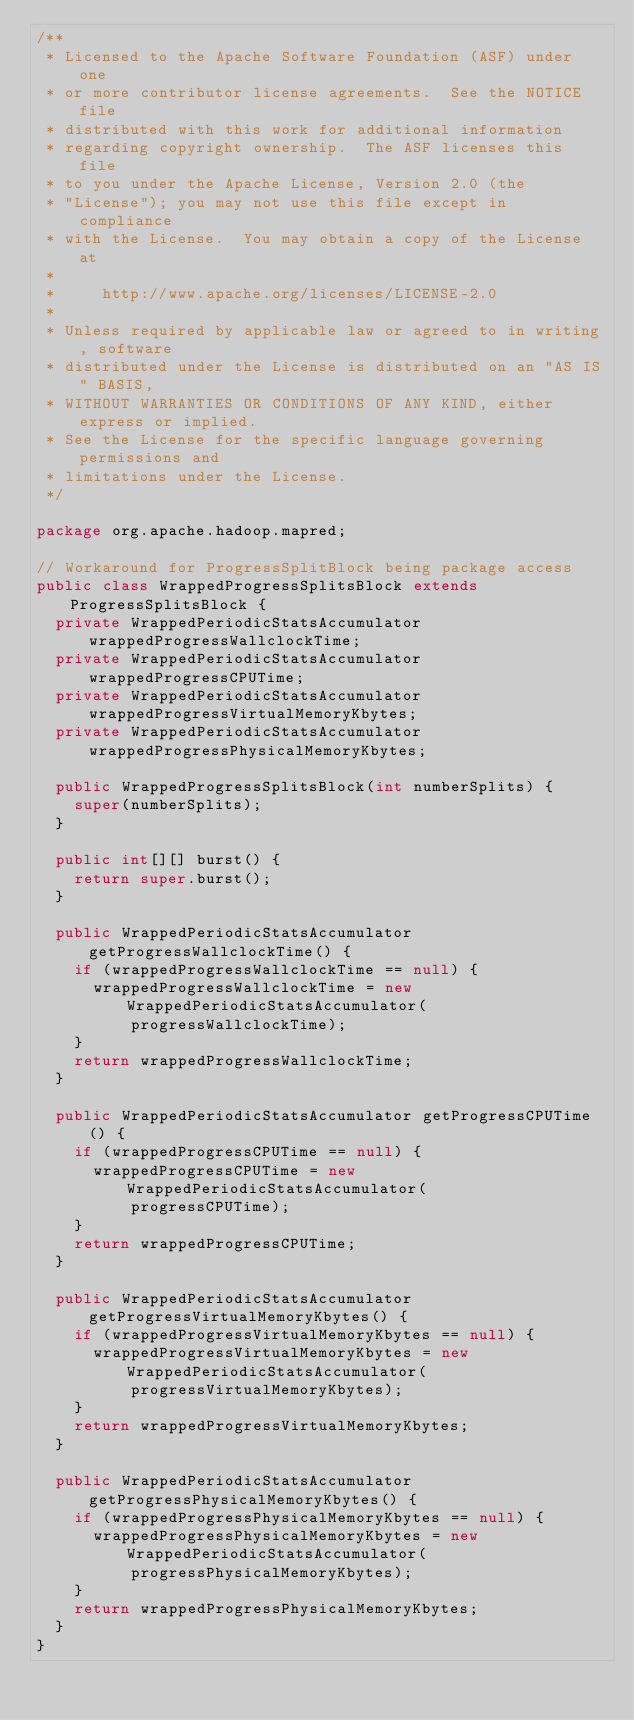Convert code to text. <code><loc_0><loc_0><loc_500><loc_500><_Java_>/**
 * Licensed to the Apache Software Foundation (ASF) under one
 * or more contributor license agreements.  See the NOTICE file
 * distributed with this work for additional information
 * regarding copyright ownership.  The ASF licenses this file
 * to you under the Apache License, Version 2.0 (the
 * "License"); you may not use this file except in compliance
 * with the License.  You may obtain a copy of the License at
 *
 *     http://www.apache.org/licenses/LICENSE-2.0
 *
 * Unless required by applicable law or agreed to in writing, software
 * distributed under the License is distributed on an "AS IS" BASIS,
 * WITHOUT WARRANTIES OR CONDITIONS OF ANY KIND, either express or implied.
 * See the License for the specific language governing permissions and
 * limitations under the License.
 */

package org.apache.hadoop.mapred;

// Workaround for ProgressSplitBlock being package access
public class WrappedProgressSplitsBlock extends ProgressSplitsBlock {
  private WrappedPeriodicStatsAccumulator wrappedProgressWallclockTime;
  private WrappedPeriodicStatsAccumulator wrappedProgressCPUTime;
  private WrappedPeriodicStatsAccumulator wrappedProgressVirtualMemoryKbytes;
  private WrappedPeriodicStatsAccumulator wrappedProgressPhysicalMemoryKbytes;

  public WrappedProgressSplitsBlock(int numberSplits) {
    super(numberSplits);
  }

  public int[][] burst() {
    return super.burst();
  }

  public WrappedPeriodicStatsAccumulator getProgressWallclockTime() {
    if (wrappedProgressWallclockTime == null) {
      wrappedProgressWallclockTime = new WrappedPeriodicStatsAccumulator(
          progressWallclockTime);
    }
    return wrappedProgressWallclockTime;
  }

  public WrappedPeriodicStatsAccumulator getProgressCPUTime() {
    if (wrappedProgressCPUTime == null) {
      wrappedProgressCPUTime = new WrappedPeriodicStatsAccumulator(
          progressCPUTime);
    }
    return wrappedProgressCPUTime;
  }

  public WrappedPeriodicStatsAccumulator getProgressVirtualMemoryKbytes() {
    if (wrappedProgressVirtualMemoryKbytes == null) {
      wrappedProgressVirtualMemoryKbytes = new WrappedPeriodicStatsAccumulator(
          progressVirtualMemoryKbytes);
    }
    return wrappedProgressVirtualMemoryKbytes;
  }

  public WrappedPeriodicStatsAccumulator getProgressPhysicalMemoryKbytes() {
    if (wrappedProgressPhysicalMemoryKbytes == null) {
      wrappedProgressPhysicalMemoryKbytes = new WrappedPeriodicStatsAccumulator(
          progressPhysicalMemoryKbytes);
    }
    return wrappedProgressPhysicalMemoryKbytes;
  }
}</code> 